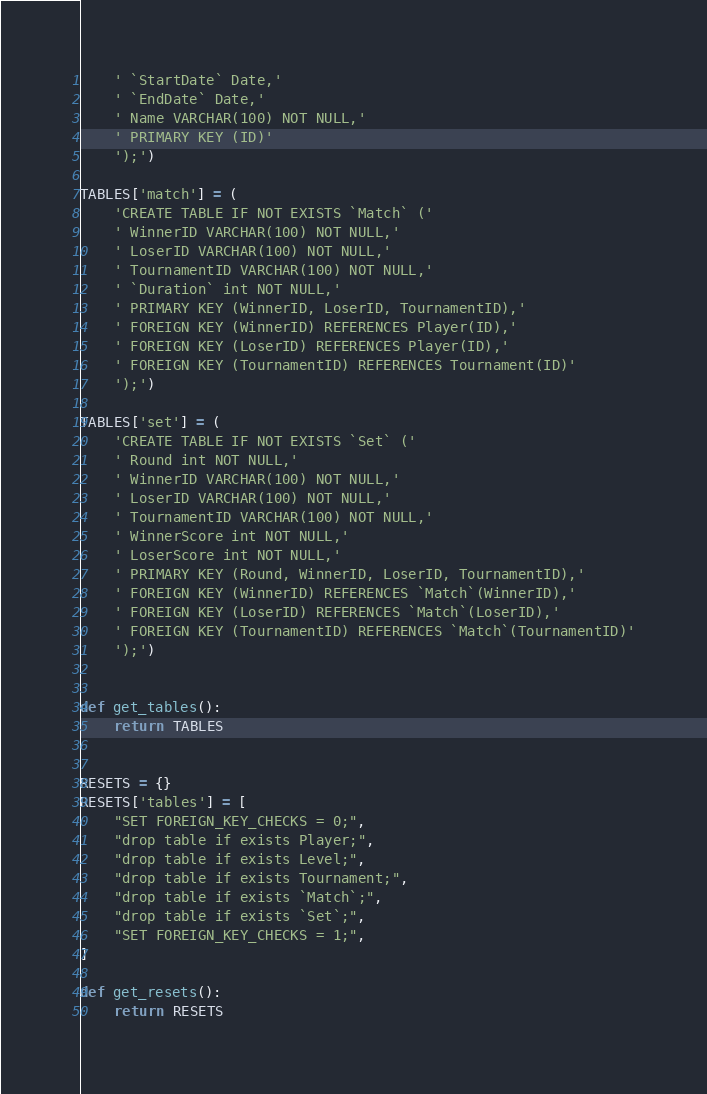Convert code to text. <code><loc_0><loc_0><loc_500><loc_500><_Python_>    ' `StartDate` Date,'
    ' `EndDate` Date,'
    ' Name VARCHAR(100) NOT NULL,'
    ' PRIMARY KEY (ID)'
    ');')

TABLES['match'] = (
    'CREATE TABLE IF NOT EXISTS `Match` ('
    ' WinnerID VARCHAR(100) NOT NULL,'
    ' LoserID VARCHAR(100) NOT NULL,'
    ' TournamentID VARCHAR(100) NOT NULL,'
    ' `Duration` int NOT NULL,'
    ' PRIMARY KEY (WinnerID, LoserID, TournamentID),'
    ' FOREIGN KEY (WinnerID) REFERENCES Player(ID),'
    ' FOREIGN KEY (LoserID) REFERENCES Player(ID),'
    ' FOREIGN KEY (TournamentID) REFERENCES Tournament(ID)'
    ');')

TABLES['set'] = (
    'CREATE TABLE IF NOT EXISTS `Set` ('
    ' Round int NOT NULL,'
    ' WinnerID VARCHAR(100) NOT NULL,'
    ' LoserID VARCHAR(100) NOT NULL,'
    ' TournamentID VARCHAR(100) NOT NULL,'
    ' WinnerScore int NOT NULL,'
    ' LoserScore int NOT NULL,'
    ' PRIMARY KEY (Round, WinnerID, LoserID, TournamentID),'
    ' FOREIGN KEY (WinnerID) REFERENCES `Match`(WinnerID),'
    ' FOREIGN KEY (LoserID) REFERENCES `Match`(LoserID),'
    ' FOREIGN KEY (TournamentID) REFERENCES `Match`(TournamentID)'
    ');')


def get_tables():
    return TABLES


RESETS = {}
RESETS['tables'] = [
    "SET FOREIGN_KEY_CHECKS = 0;",
    "drop table if exists Player;",
    "drop table if exists Level;",
    "drop table if exists Tournament;",
    "drop table if exists `Match`;",
    "drop table if exists `Set`;",
    "SET FOREIGN_KEY_CHECKS = 1;",
]

def get_resets():
    return RESETS</code> 